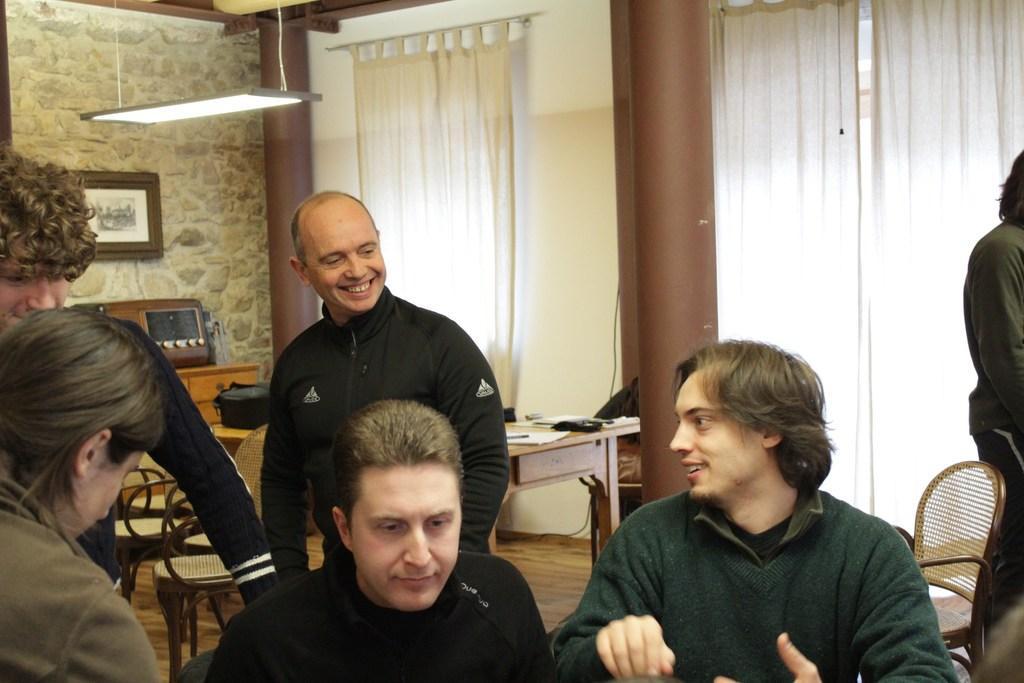Describe this image in one or two sentences. As we can see in the image there are few people here and there, chairs, table, oven, photo frame, light, wall and curtains. On table there is a bag and curtain. 